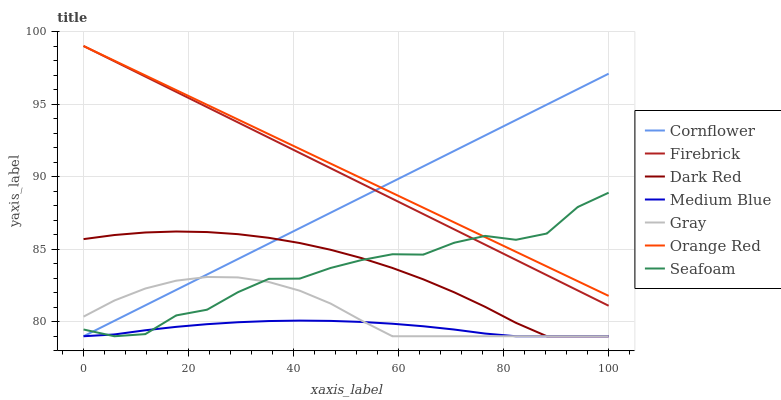Does Medium Blue have the minimum area under the curve?
Answer yes or no. Yes. Does Orange Red have the maximum area under the curve?
Answer yes or no. Yes. Does Gray have the minimum area under the curve?
Answer yes or no. No. Does Gray have the maximum area under the curve?
Answer yes or no. No. Is Orange Red the smoothest?
Answer yes or no. Yes. Is Seafoam the roughest?
Answer yes or no. Yes. Is Gray the smoothest?
Answer yes or no. No. Is Gray the roughest?
Answer yes or no. No. Does Firebrick have the lowest value?
Answer yes or no. No. Does Gray have the highest value?
Answer yes or no. No. Is Dark Red less than Orange Red?
Answer yes or no. Yes. Is Orange Red greater than Medium Blue?
Answer yes or no. Yes. Does Dark Red intersect Orange Red?
Answer yes or no. No. 